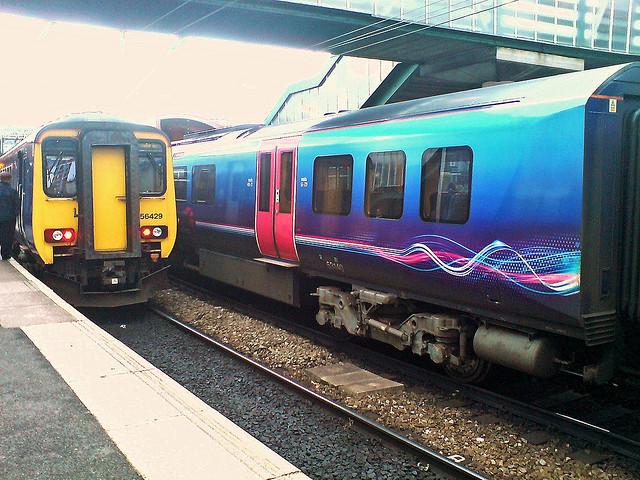Is the yellow train moving?
Quick response, please. No. What color are the train doors on the right?
Quick response, please. Red. What shape are the windows?
Keep it brief. Square. 